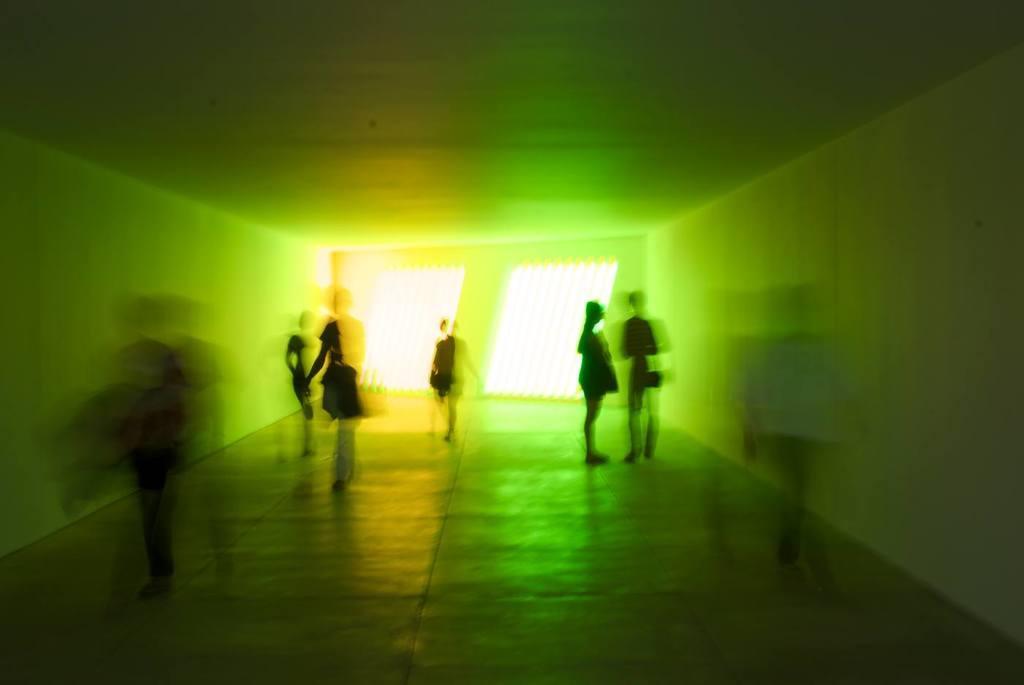Can you describe this image briefly? It is a blurry image. In this image I can see the walls, people and objects.   